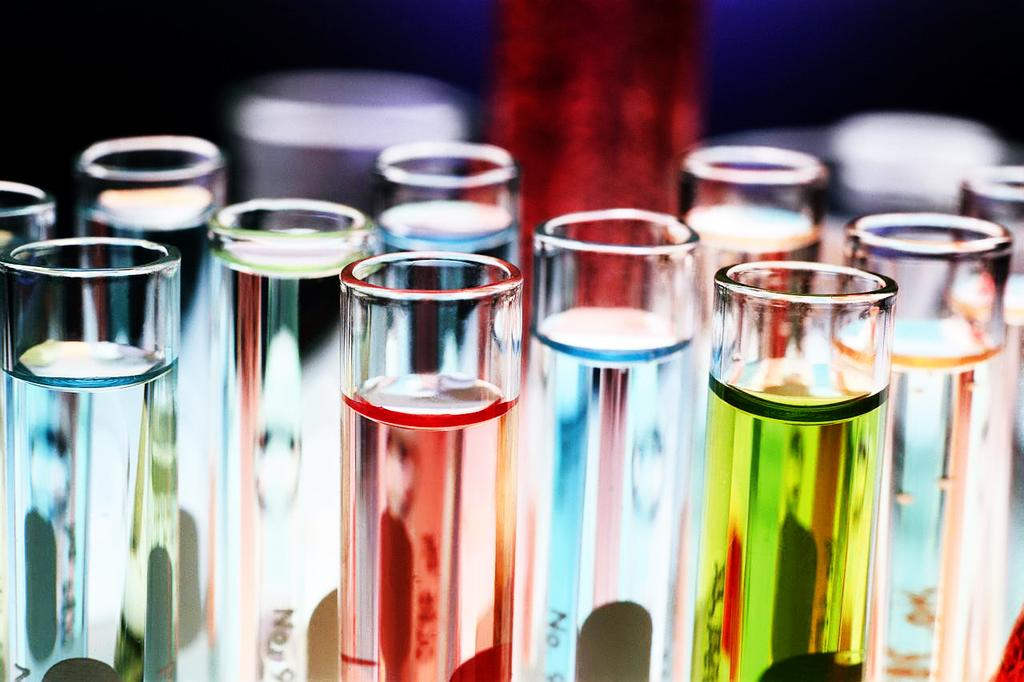Provide a one-sentence caption for the provided image. Several chemistry tubes with various colored liquids labeled with various numbers including No 9. 